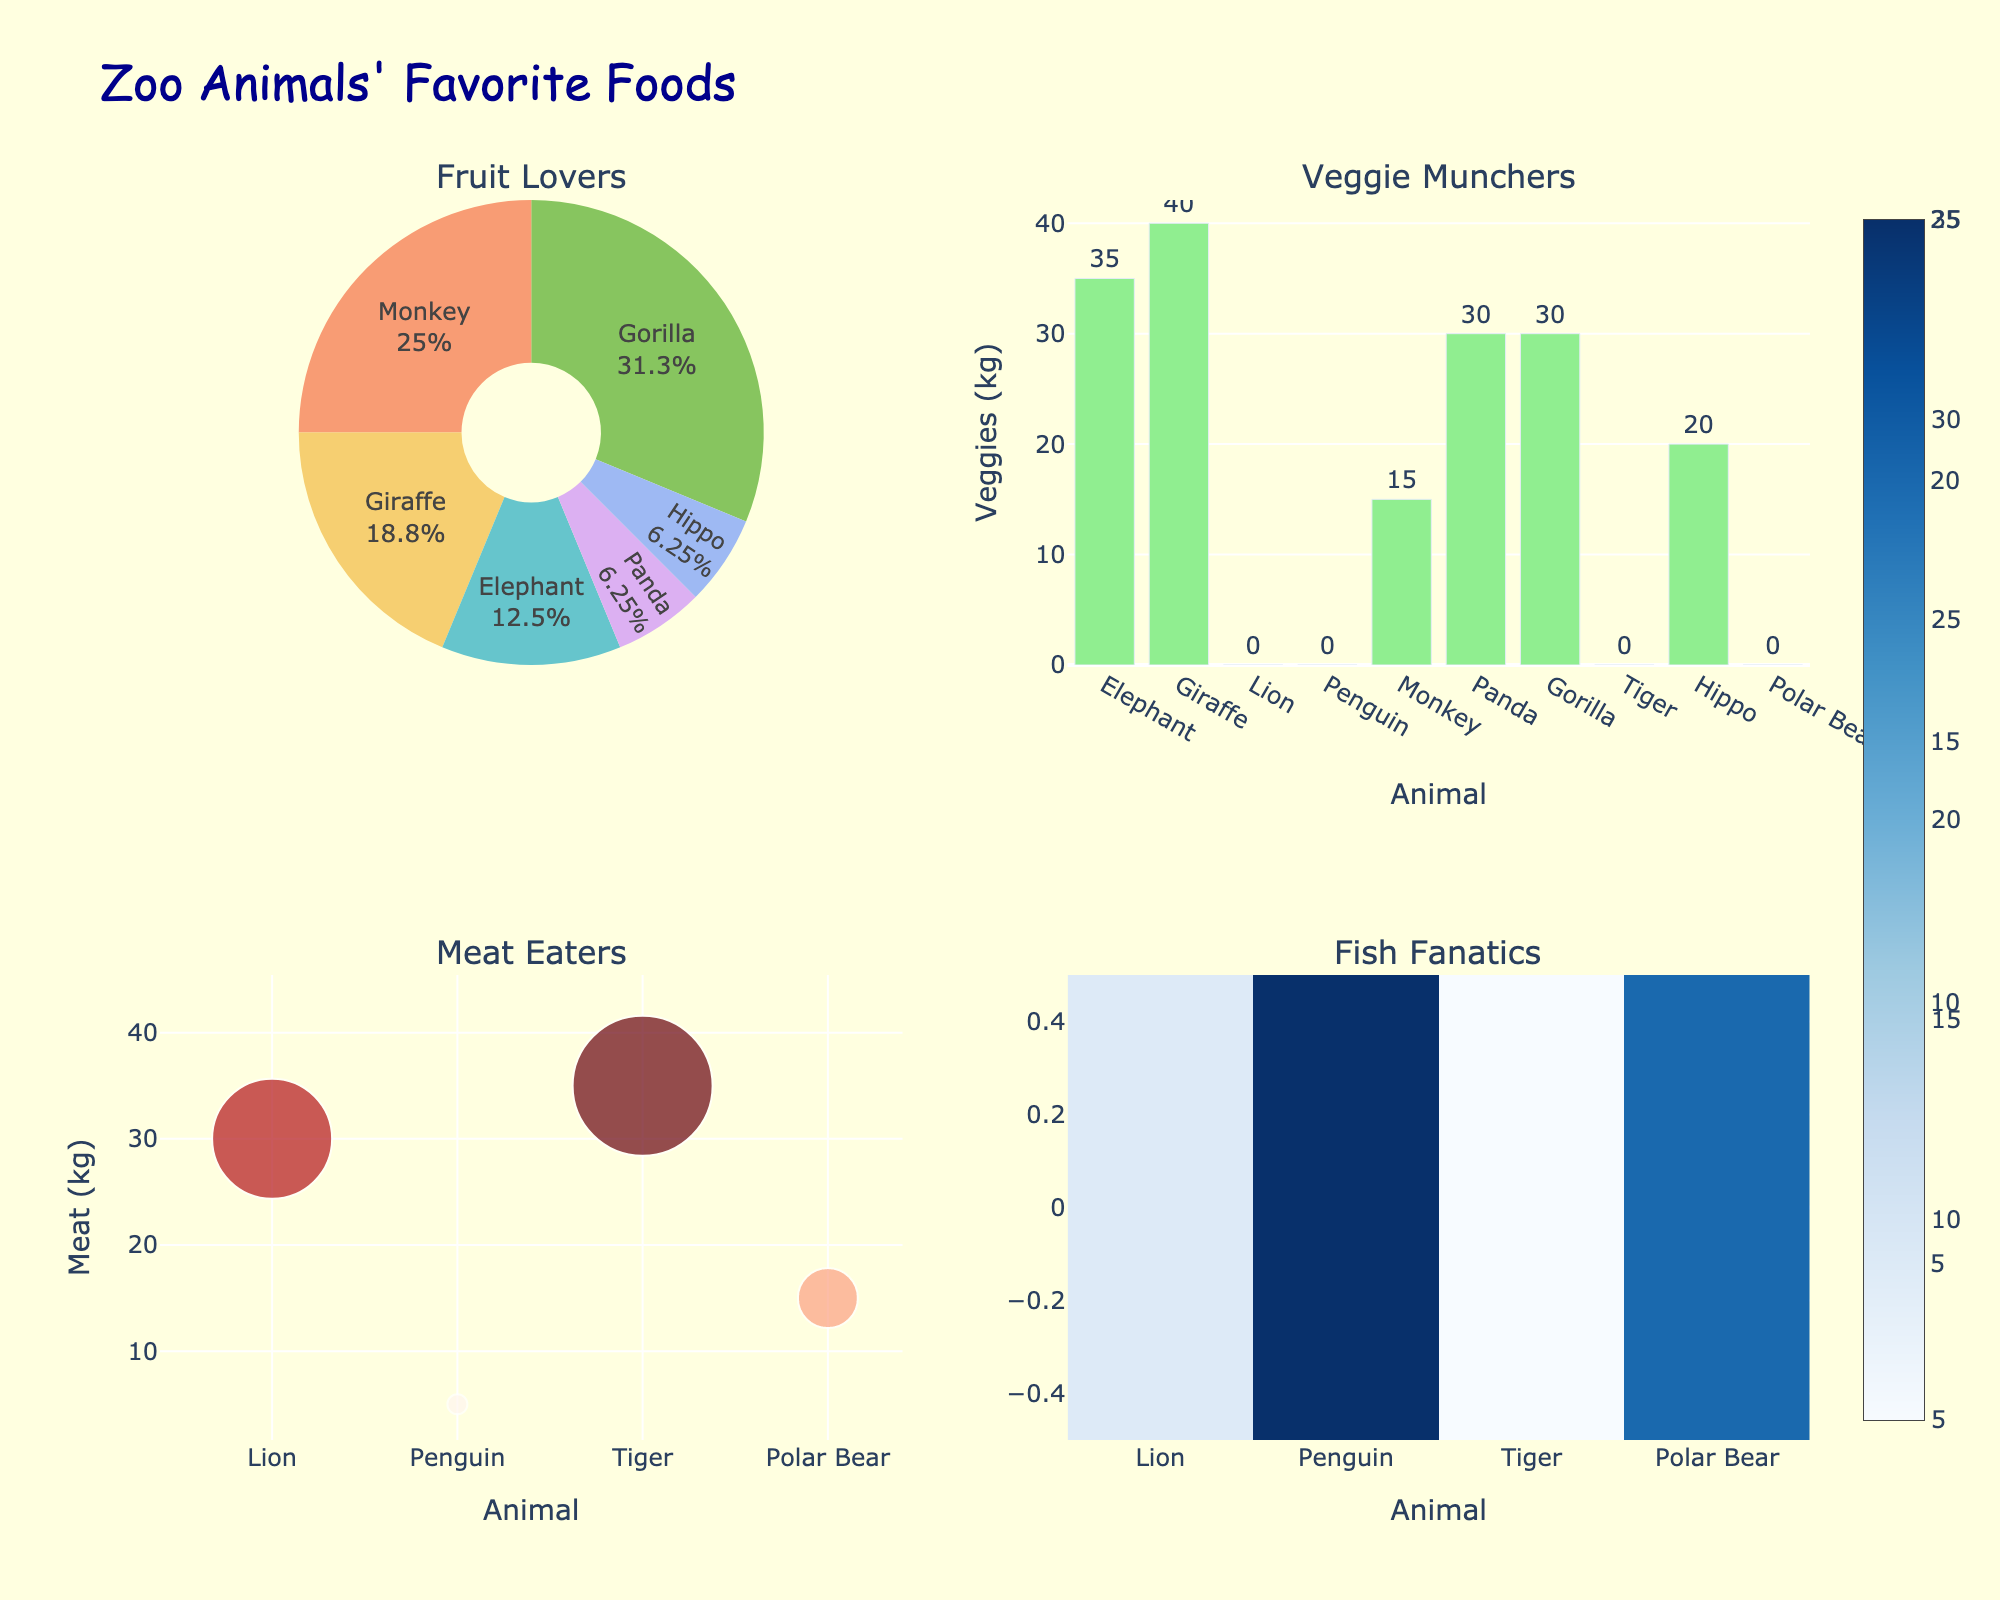What's the title of the figure? The title is usually located at the top of the figure. In this case, it reads "Zoo Animals' Favorite Foods"
Answer: Zoo Animals' Favorite Foods Which animals prefer to eat fruit? Look at the Pie chart labeled "Fruit Lovers"; it shows the animals and the percentage of fruit they like.
Answer: Elephant, Giraffe, Monkey, Panda, Gorilla, Hippo Which animal likes vegetables the most? Refer to the Bar chart labeled "Veggie Munchers"; compare the height of the bars to see which animal has the highest number of units.
Answer: Giraffe Which animal eats the most meat? Look at the Scatter plot labeled "Meat Eaters"; the animal with the highest value on the y-axis prefers the most meat.
Answer: Tiger Which animal prefers fish the most? Refer to the Heatmap labeled "Fish Fanatics"; the animal with the darkest color (highest value) on the x-axis.
Answer: Penguin How many types of each food do the animals prefer? Count the unique labels or categories in each subplot (Pie chart for fruit, Bar chart for vegetables, Scatter plot for meat, Heatmap for fish).
Answer: 6 (Fruit), 10 (Vegetables), 4 (Meat), 4 (Fish) What's the difference in vegetable consumption between the Giraffe and the Panda? Find the bar height for Giraffe and Panda in the "Veggie Munchers" chart. Giraffe: 40, Panda: 30. Subtract the smaller from the larger value: 40 - 30 = 10.
Answer: 10 Which animals prefer to eat both meat and fish? Check both the Scatter plot for meat-eaters and the Heatmap for fish-eaters; look for common labels.
Answer: Lion, Tiger, Penguin, Polar Bear What's the combined percentage of fruit consumption for the Monkey and the Gorilla? Look at the Pie chart for fruit; find the percentage for Monkey and Gorilla and add them together.
Answer: 45% Is there any animal that does not prefer fruit, vegetables, meat, or fish? Check all the subplots; every animal listed should be present in at least one of the charts.
Answer: No 